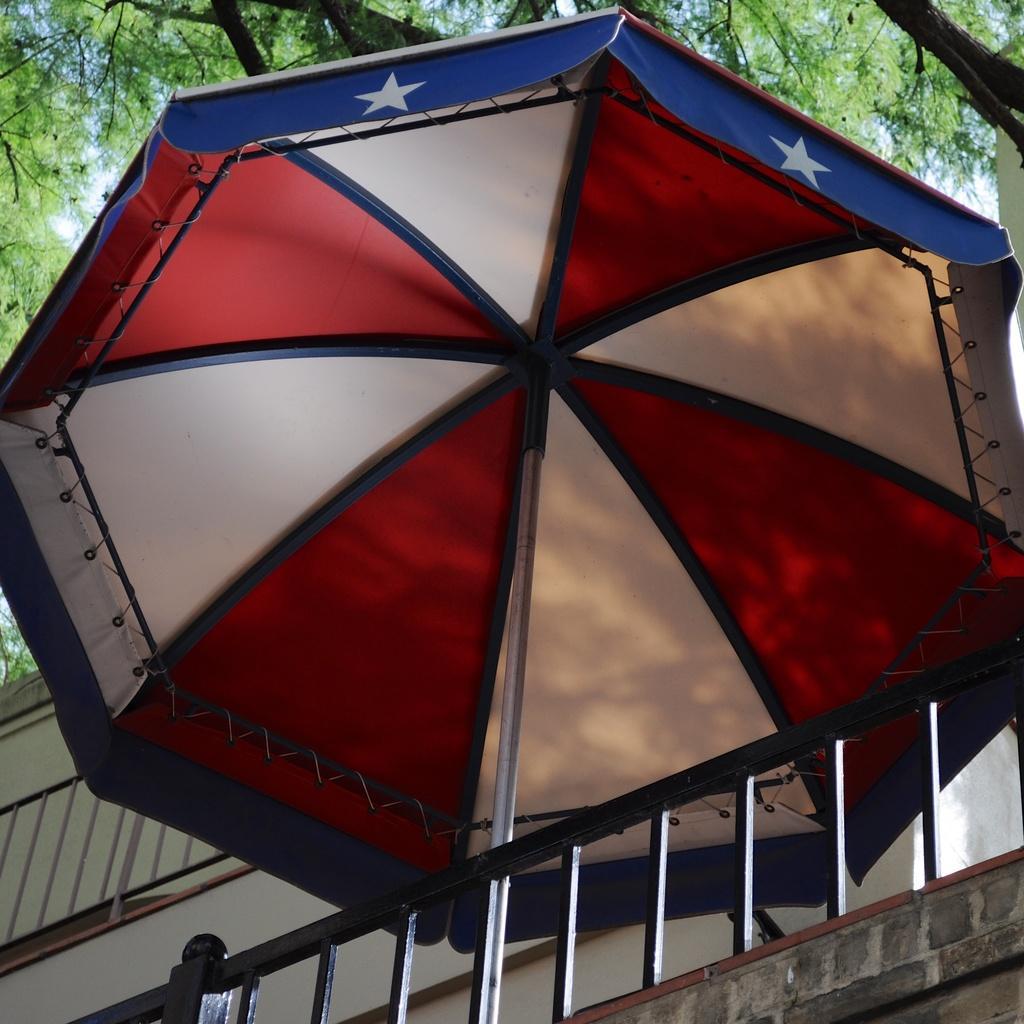Describe this image in one or two sentences. This picture shows a building and an umbrella and we see trees and a blue sky. 